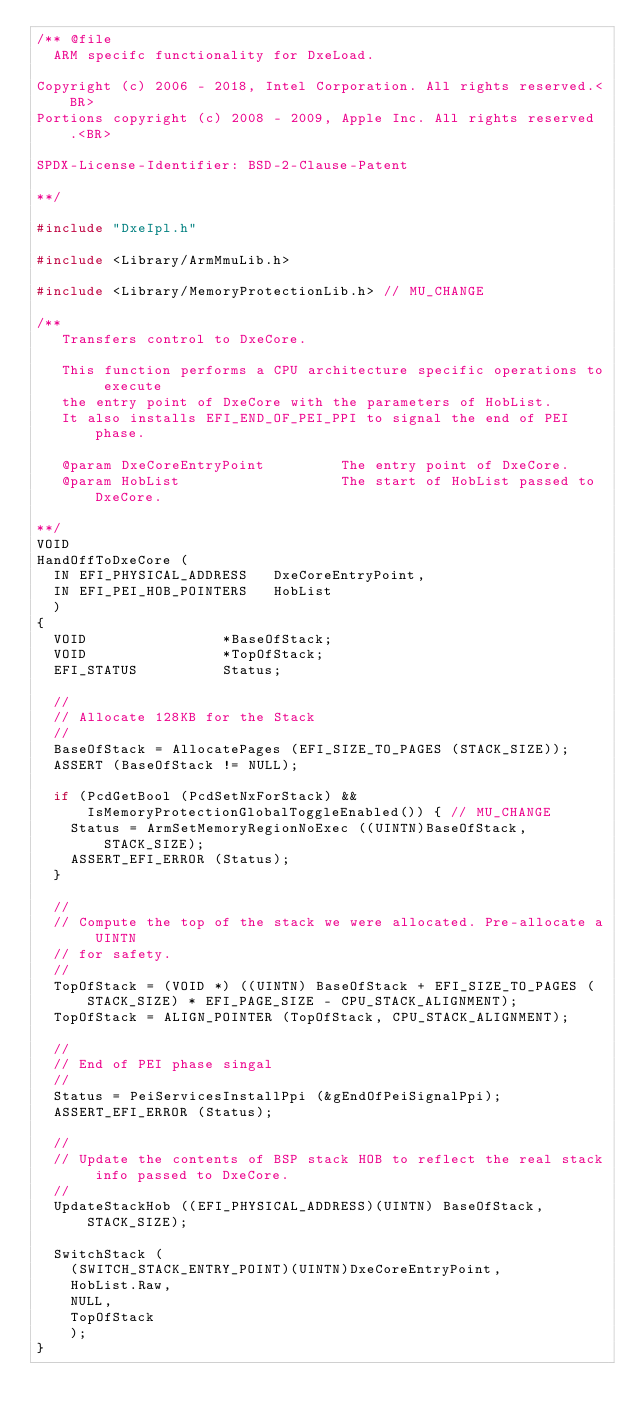Convert code to text. <code><loc_0><loc_0><loc_500><loc_500><_C_>/** @file
  ARM specifc functionality for DxeLoad.

Copyright (c) 2006 - 2018, Intel Corporation. All rights reserved.<BR>
Portions copyright (c) 2008 - 2009, Apple Inc. All rights reserved.<BR>

SPDX-License-Identifier: BSD-2-Clause-Patent

**/

#include "DxeIpl.h"

#include <Library/ArmMmuLib.h>

#include <Library/MemoryProtectionLib.h> // MU_CHANGE

/**
   Transfers control to DxeCore.

   This function performs a CPU architecture specific operations to execute
   the entry point of DxeCore with the parameters of HobList.
   It also installs EFI_END_OF_PEI_PPI to signal the end of PEI phase.

   @param DxeCoreEntryPoint         The entry point of DxeCore.
   @param HobList                   The start of HobList passed to DxeCore.

**/
VOID
HandOffToDxeCore (
  IN EFI_PHYSICAL_ADDRESS   DxeCoreEntryPoint,
  IN EFI_PEI_HOB_POINTERS   HobList
  )
{
  VOID                *BaseOfStack;
  VOID                *TopOfStack;
  EFI_STATUS          Status;

  //
  // Allocate 128KB for the Stack
  //
  BaseOfStack = AllocatePages (EFI_SIZE_TO_PAGES (STACK_SIZE));
  ASSERT (BaseOfStack != NULL);

  if (PcdGetBool (PcdSetNxForStack) && IsMemoryProtectionGlobalToggleEnabled()) { // MU_CHANGE 
    Status = ArmSetMemoryRegionNoExec ((UINTN)BaseOfStack, STACK_SIZE);
    ASSERT_EFI_ERROR (Status);
  }

  //
  // Compute the top of the stack we were allocated. Pre-allocate a UINTN
  // for safety.
  //
  TopOfStack = (VOID *) ((UINTN) BaseOfStack + EFI_SIZE_TO_PAGES (STACK_SIZE) * EFI_PAGE_SIZE - CPU_STACK_ALIGNMENT);
  TopOfStack = ALIGN_POINTER (TopOfStack, CPU_STACK_ALIGNMENT);

  //
  // End of PEI phase singal
  //
  Status = PeiServicesInstallPpi (&gEndOfPeiSignalPpi);
  ASSERT_EFI_ERROR (Status);

  //
  // Update the contents of BSP stack HOB to reflect the real stack info passed to DxeCore.
  //
  UpdateStackHob ((EFI_PHYSICAL_ADDRESS)(UINTN) BaseOfStack, STACK_SIZE);

  SwitchStack (
    (SWITCH_STACK_ENTRY_POINT)(UINTN)DxeCoreEntryPoint,
    HobList.Raw,
    NULL,
    TopOfStack
    );
}
</code> 